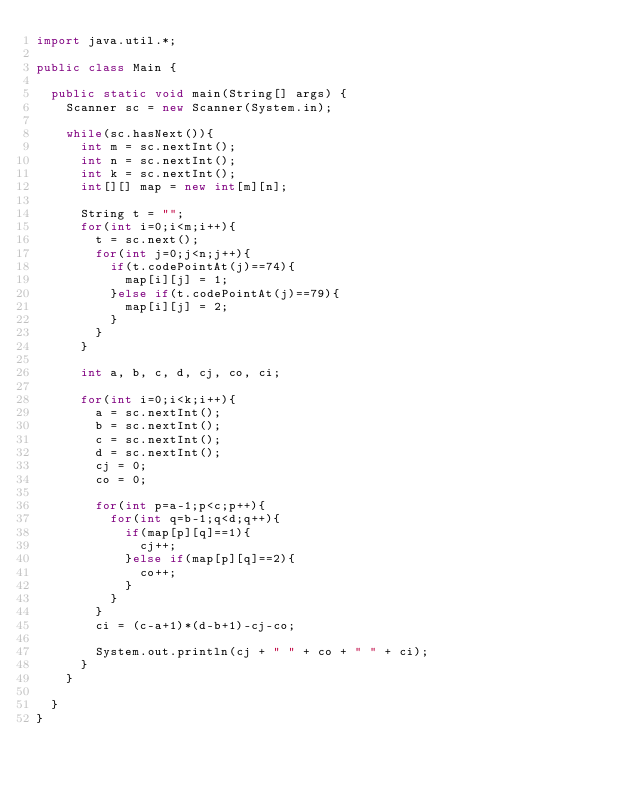Convert code to text. <code><loc_0><loc_0><loc_500><loc_500><_Java_>import java.util.*;

public class Main {
	
	public static void main(String[] args) {
		Scanner sc = new Scanner(System.in);
		
		while(sc.hasNext()){
			int m = sc.nextInt();
			int n = sc.nextInt();
			int k = sc.nextInt();
			int[][] map = new int[m][n];
			
			String t = "";
			for(int i=0;i<m;i++){
				t = sc.next();
				for(int j=0;j<n;j++){
					if(t.codePointAt(j)==74){
						map[i][j] = 1;
					}else if(t.codePointAt(j)==79){
						map[i][j] = 2;
					}
				}
			}
			
			int a, b, c, d, cj, co, ci;
			
			for(int i=0;i<k;i++){
				a = sc.nextInt();
				b = sc.nextInt();
				c = sc.nextInt();
				d = sc.nextInt();
				cj = 0;
				co = 0;
				
				for(int p=a-1;p<c;p++){
					for(int q=b-1;q<d;q++){
						if(map[p][q]==1){
							cj++;
						}else if(map[p][q]==2){
							co++;
						}
					}
				}
				ci = (c-a+1)*(d-b+1)-cj-co;
				
				System.out.println(cj + " " + co + " " + ci);
			}
		}
	
	}	
}</code> 